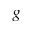Convert formula to latex. <formula><loc_0><loc_0><loc_500><loc_500>g</formula> 